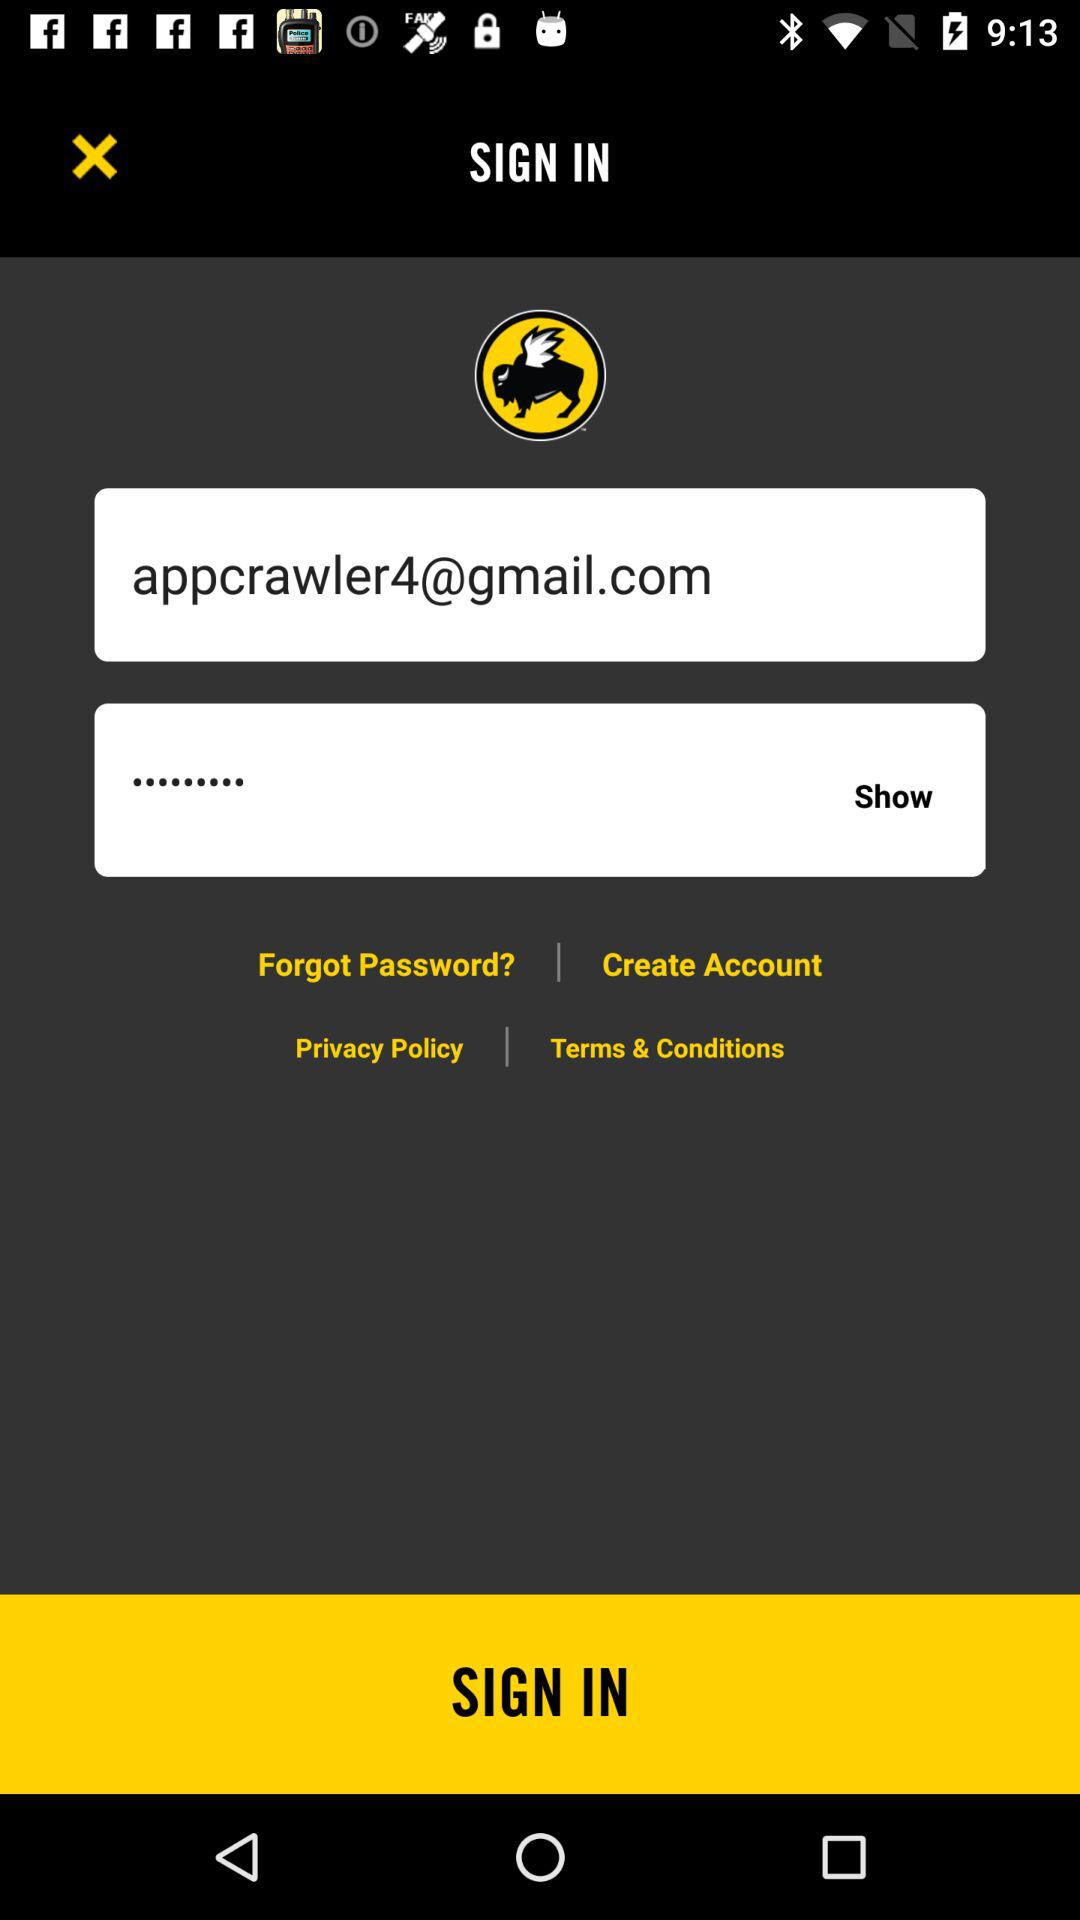Which tab is selected? The selected tab is "LOCATIONS". 